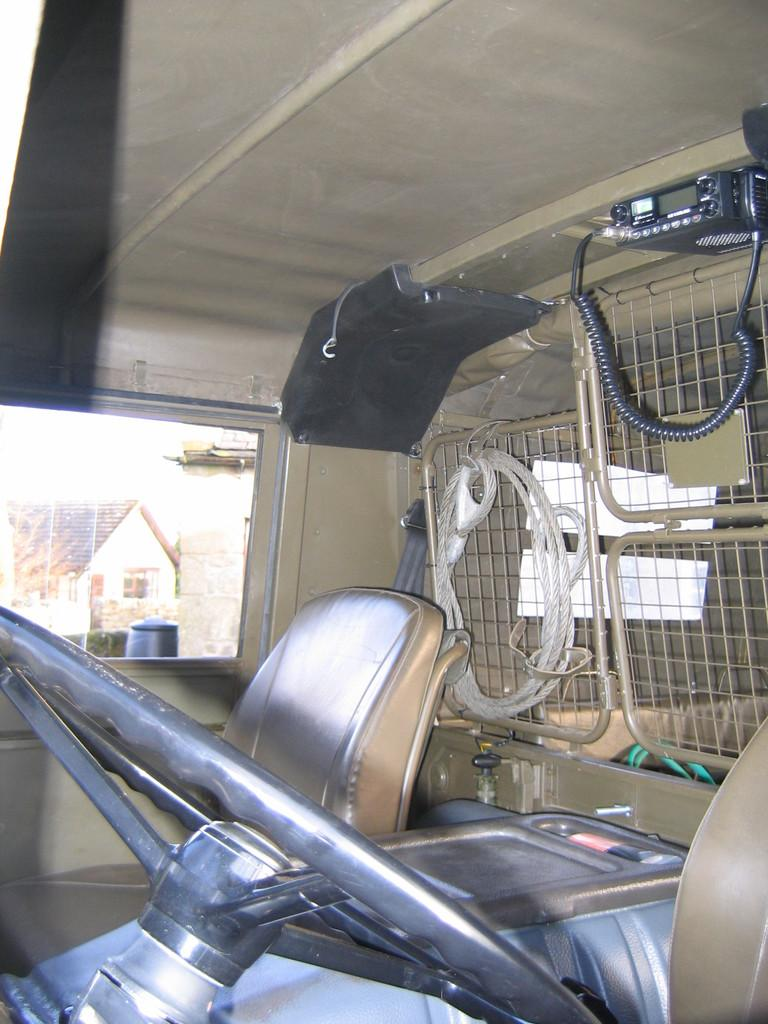What type of setting is depicted in the image? The image shows an inside view of a vehicle. What is used to control the direction of the vehicle? There is a steering wheel in the vehicle. How many seats are visible in the front of the vehicle? There are seats in the front of the vehicle. What device is present on the right side of the vehicle? There is an amplifier on the right side of the vehicle. What can be seen in the background of the image? There is a house visible in the background of the image. Is there any blood visible on the seats in the image? No, there is no blood visible on the seats in the image. Can you see a goose walking near the house in the background? No, there is no goose visible in the image. 